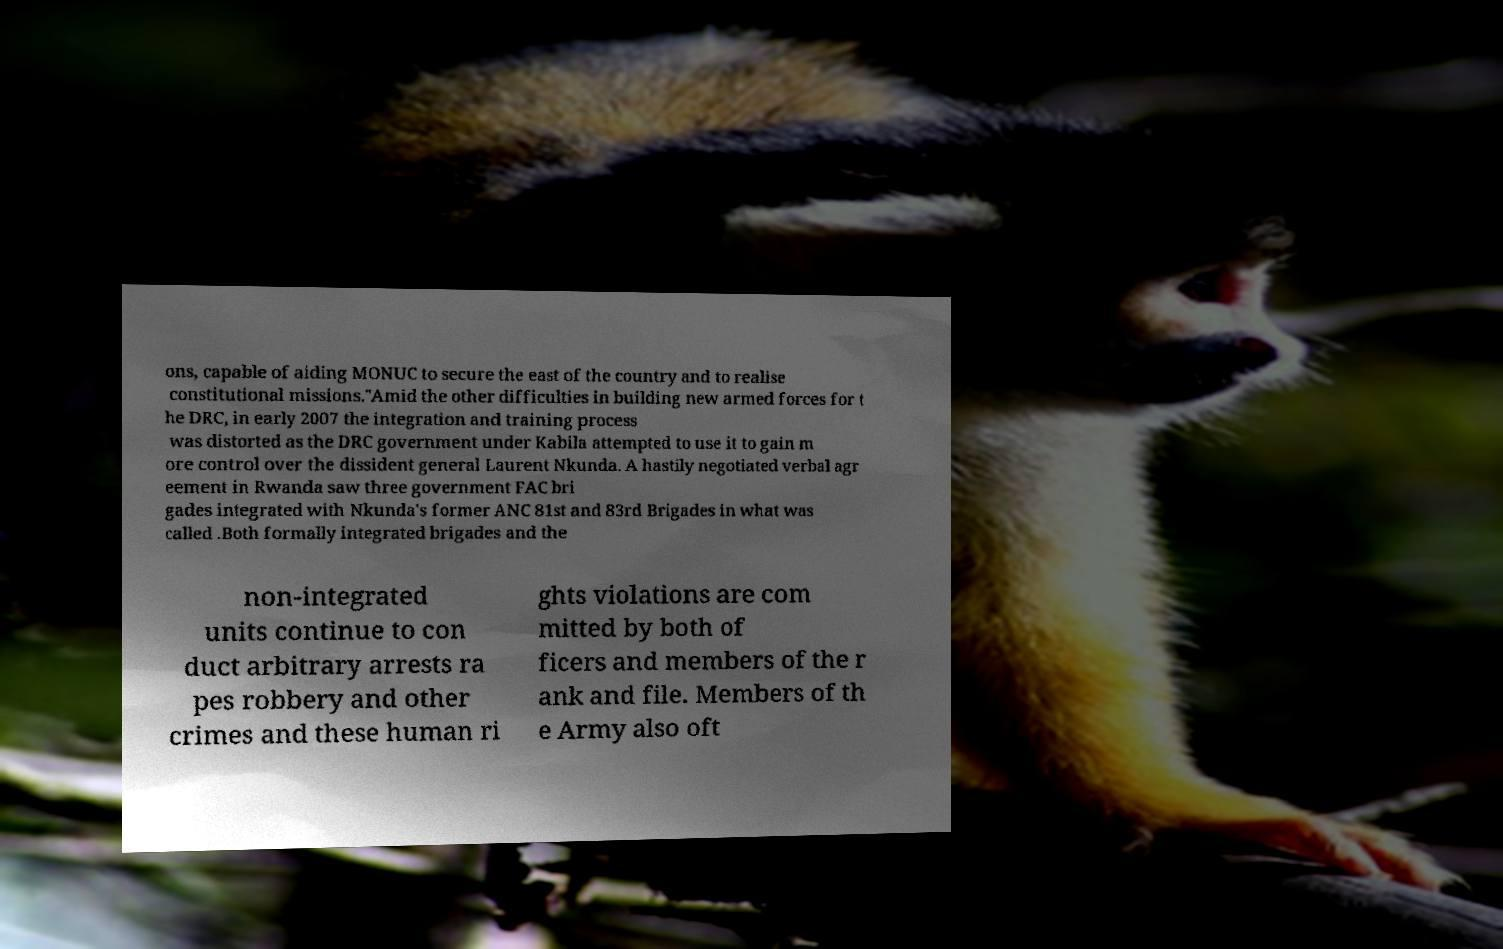Could you extract and type out the text from this image? ons, capable of aiding MONUC to secure the east of the country and to realise constitutional missions."Amid the other difficulties in building new armed forces for t he DRC, in early 2007 the integration and training process was distorted as the DRC government under Kabila attempted to use it to gain m ore control over the dissident general Laurent Nkunda. A hastily negotiated verbal agr eement in Rwanda saw three government FAC bri gades integrated with Nkunda's former ANC 81st and 83rd Brigades in what was called .Both formally integrated brigades and the non-integrated units continue to con duct arbitrary arrests ra pes robbery and other crimes and these human ri ghts violations are com mitted by both of ficers and members of the r ank and file. Members of th e Army also oft 